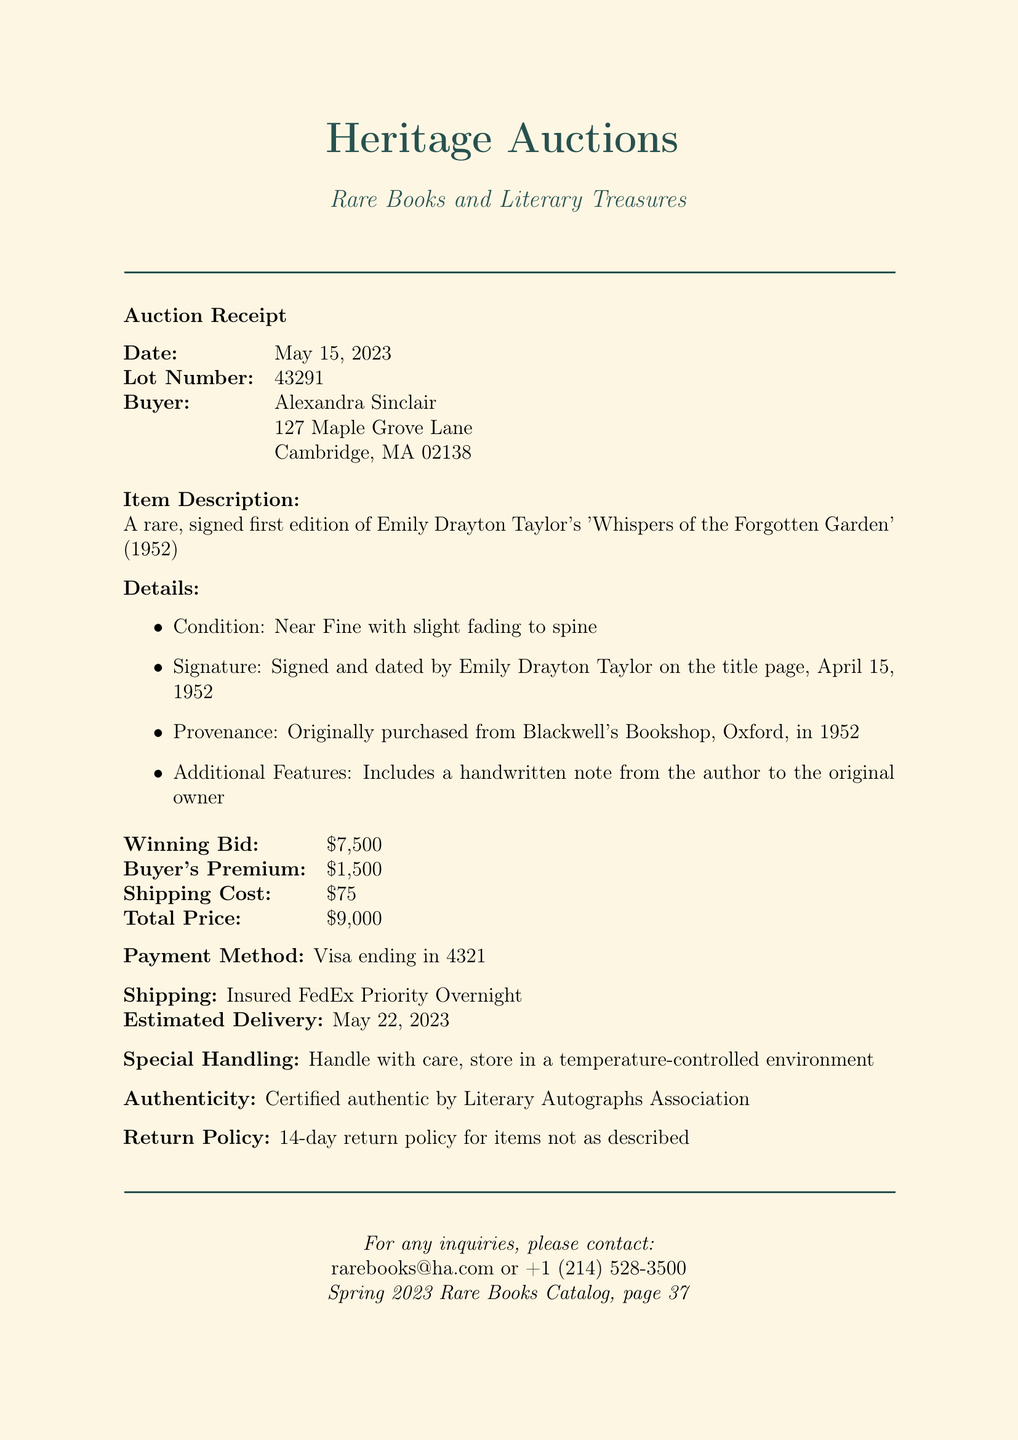What is the auction date? The auction date is specified in the document as May 15, 2023.
Answer: May 15, 2023 Who is the buyer? The document shows the name of the buyer as Alexandra Sinclair.
Answer: Alexandra Sinclair What is the winning bid amount? The winning bid amount is clearly listed in the document as $7,500.
Answer: $7,500 What is included with the book? The document mentions that the book includes a handwritten note from the author to the original owner.
Answer: A handwritten note What is the total price paid? The total price is calculated as the sum of the winning bid and buyer's premium, stated in the document as $9,000.
Answer: $9,000 What is the book's condition? The condition of the book is described as Near Fine with slight fading to spine.
Answer: Near Fine with slight fading to spine When is the estimated delivery date? The estimated delivery date is specifically provided in the document as May 22, 2023.
Answer: May 22, 2023 Who was the seller? The seller's name is mentioned in the document as the Estate of Margaret Atwood.
Answer: Estate of Margaret Atwood What is the return policy? The document outlines a 14-day return policy for items not as described.
Answer: 14-day return policy 